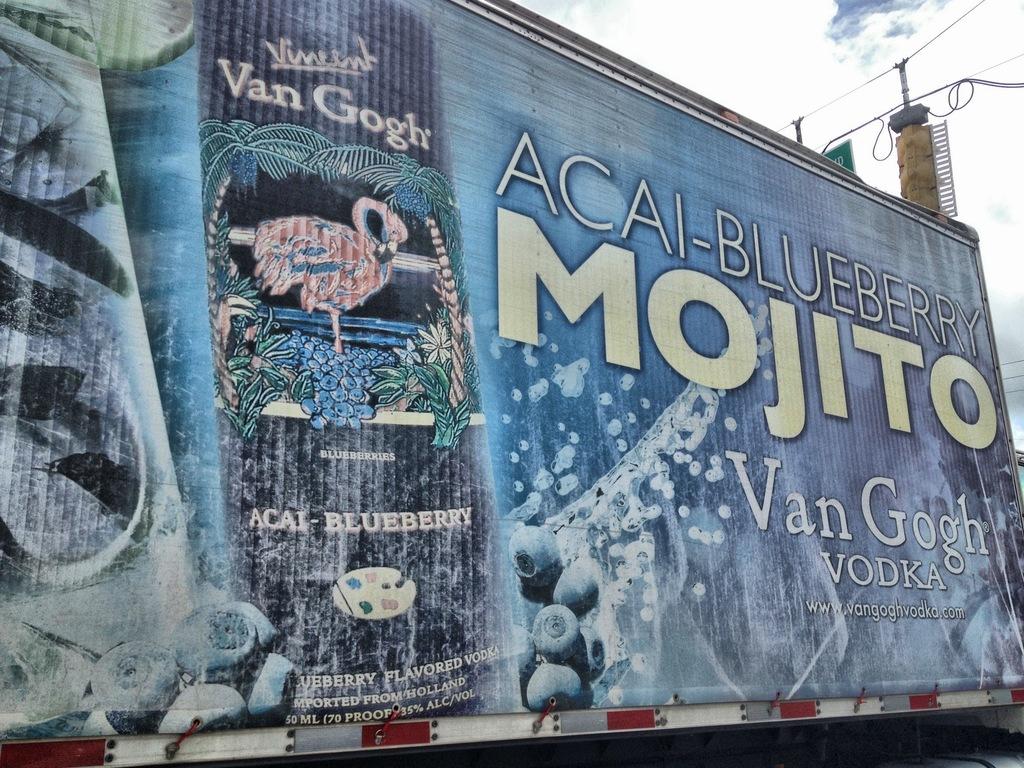What flavor is this?
Make the answer very short. Acai-blueberry. What type of alcoholic beverage is advertised?
Offer a very short reply. Mojito. 